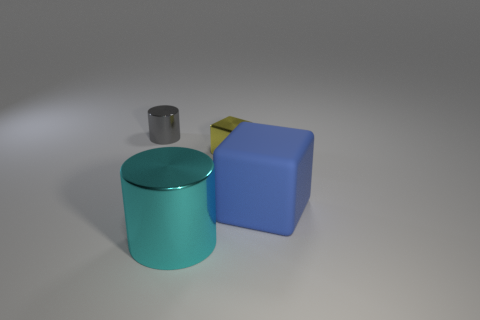Add 4 green matte spheres. How many objects exist? 8 Subtract 1 cylinders. How many cylinders are left? 1 Subtract all gray cylinders. How many cylinders are left? 1 Subtract 1 yellow blocks. How many objects are left? 3 Subtract all blue blocks. Subtract all cyan spheres. How many blocks are left? 1 Subtract all gray blocks. How many gray cylinders are left? 1 Subtract all blue cubes. Subtract all small gray metal things. How many objects are left? 2 Add 4 cyan shiny things. How many cyan shiny things are left? 5 Add 3 brown objects. How many brown objects exist? 3 